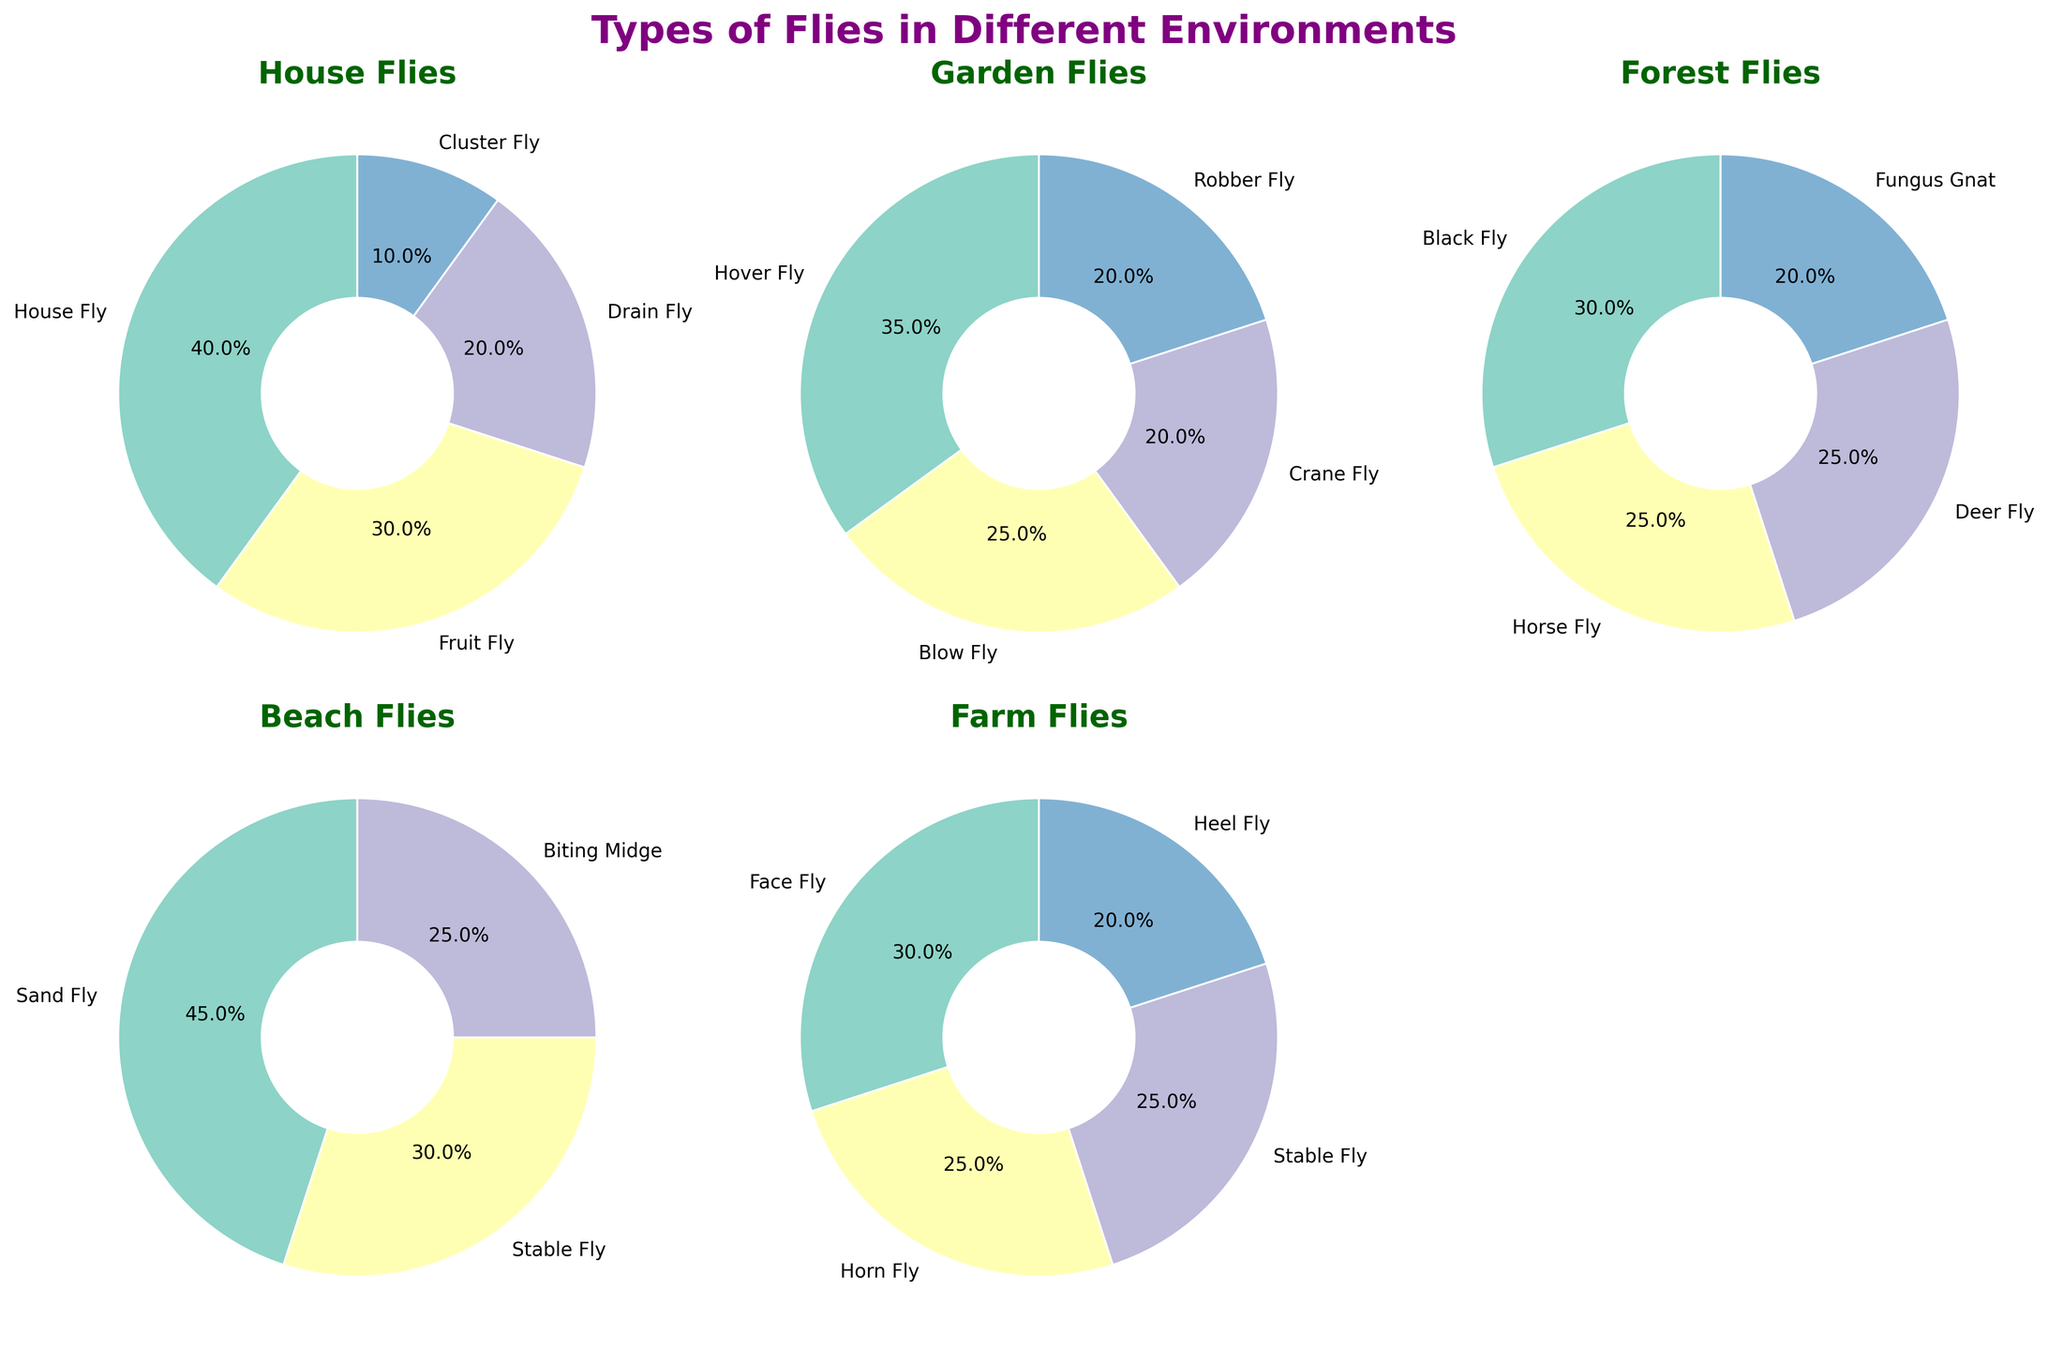Which environment has the highest percentage of House Flyers? The pie chart for the 'House' environment shows different types of flies, and the largest slice belongs to House Fly with 40%.
Answer: House Which environments have the same percentage of any type of fly? By examining the pie charts, both the 'Garden' and the 'Farm' environments have 20% for Crane Fly and Heel Fly respectively.
Answer: Garden and Farm Which fly type has the largest slice in the beach environment? The pie chart for the 'Beach' environment shows Sand Fly having the largest slice at 45%.
Answer: Sand Fly What's the total percentage of all types of flies in the 'Forest' environment? Adding up the percentages given in the pie chart for the 'Forest' environment: 30% (Black Fly) + 25% (Horse Fly) + 25% (Deer Fly) + 20% (Fungus Gnat) = 100%.
Answer: 100% Which types of flies are found in both the 'House' and 'Farm' environments? By looking at pie charts of both environments, the Stable Fly is present in both 'House' and 'Farm' environments.
Answer: Stable Fly Which environment has the highest diversity of fly types in terms of unique fly types? Each environment shows distinctive fly types: 'House' has House Fly, Fruit Fly, Drain Fly, Cluster Fly (4 types); 'Garden' has Hover Fly, Blow Fly, Crane Fly, Robber Fly (4 types); 'Forest' has Black Fly, Horse Fly, Deer Fly, Fungus Gnat (4 types); 'Beach' has Sand Fly, Stable Fly, Biting Midge (3 types); 'Farm' has Face Fly, Horn Fly, Stable Fly, Heel Fly (4 types). All (House, Garden, Forest, Farm) have 4 unique types.
Answer: House, Garden, Forest, Farm What is the combined percentage of Cluster Fly and Sand Fly across all environments? From the charts: Cluster Fly (House: 10%) + Sand Fly (Beach: 45%) = 55%.
Answer: 55% 